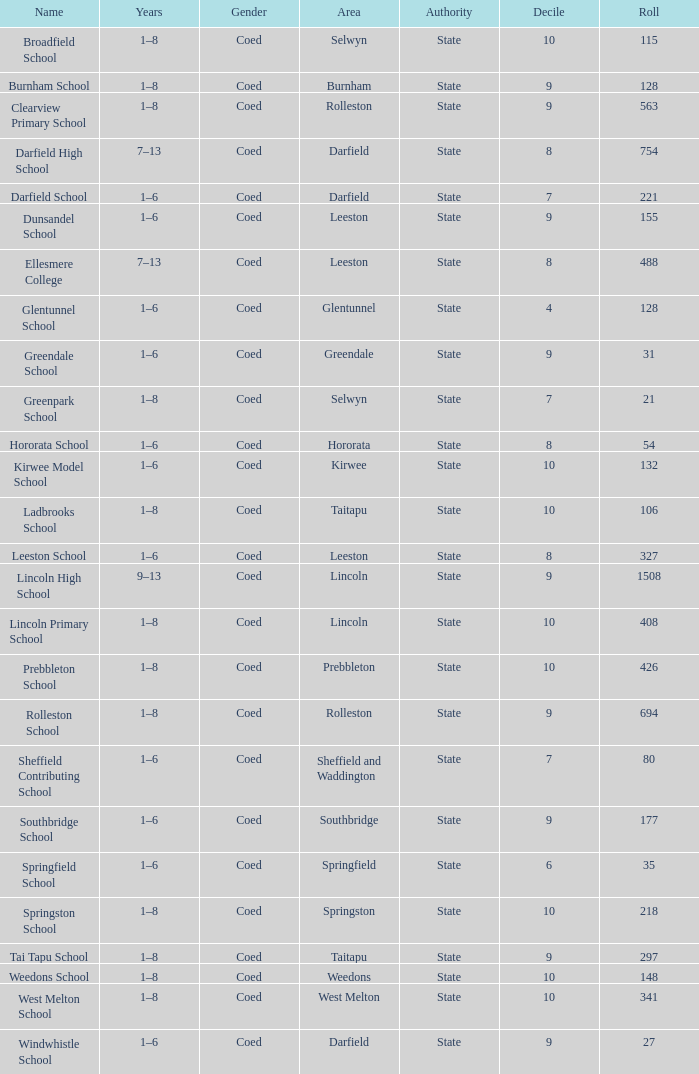How many deciles have Years of 9–13? 1.0. 